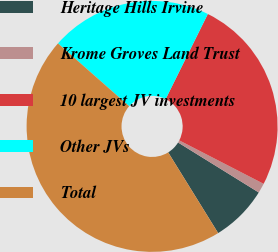<chart> <loc_0><loc_0><loc_500><loc_500><pie_chart><fcel>Heritage Hills Irvine<fcel>Krome Groves Land Trust<fcel>10 largest JV investments<fcel>Other JVs<fcel>Total<nl><fcel>7.35%<fcel>1.26%<fcel>25.24%<fcel>20.83%<fcel>45.32%<nl></chart> 